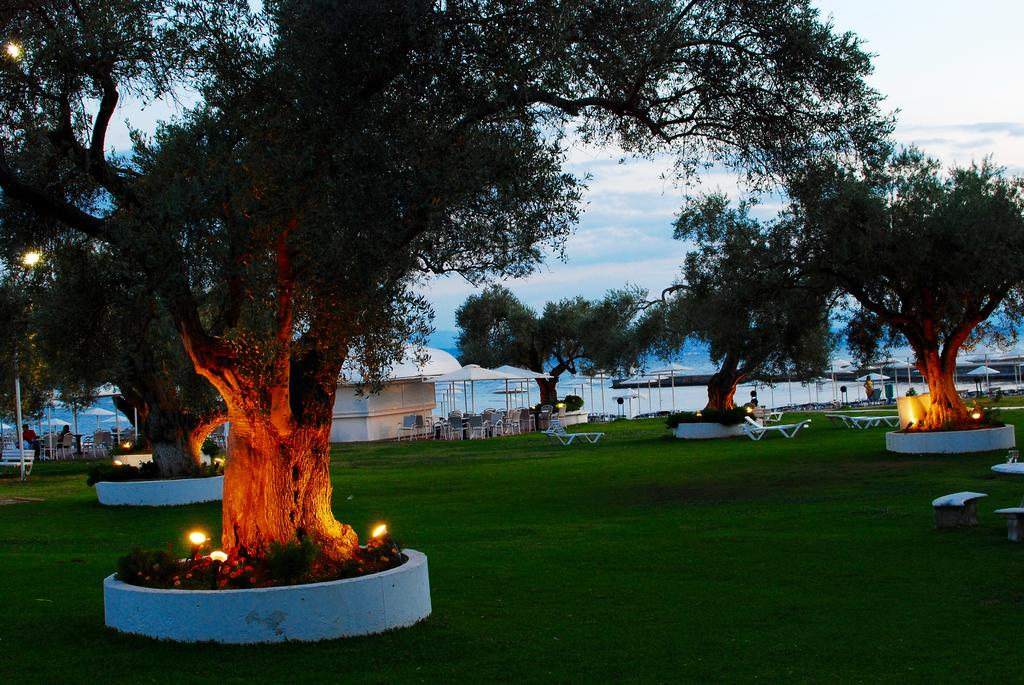What type of vegetation can be seen in the image? There are trees in the image. What is unique about the lighting in the image? There are lights under the trees in the image. What type of temporary shelter is present in the image? There are tents in the image. What type of seating is available in the image? There is a bench in the image. What objects can be found on the ground in the image? There are objects on the ground in the image. What type of structure is present in the image? There is a shed in the image. What can be seen in the background of the image? The sky with clouds is visible in the background of the image. What is the source of water visible in the image? The facts provided do not specify the source of water, only that it is visible in the image. How does the design of the attention-grabbing object affect the overall aesthetic of the image? There is no attention-grabbing object mentioned in the provided facts, so it is not possible to answer this question. 